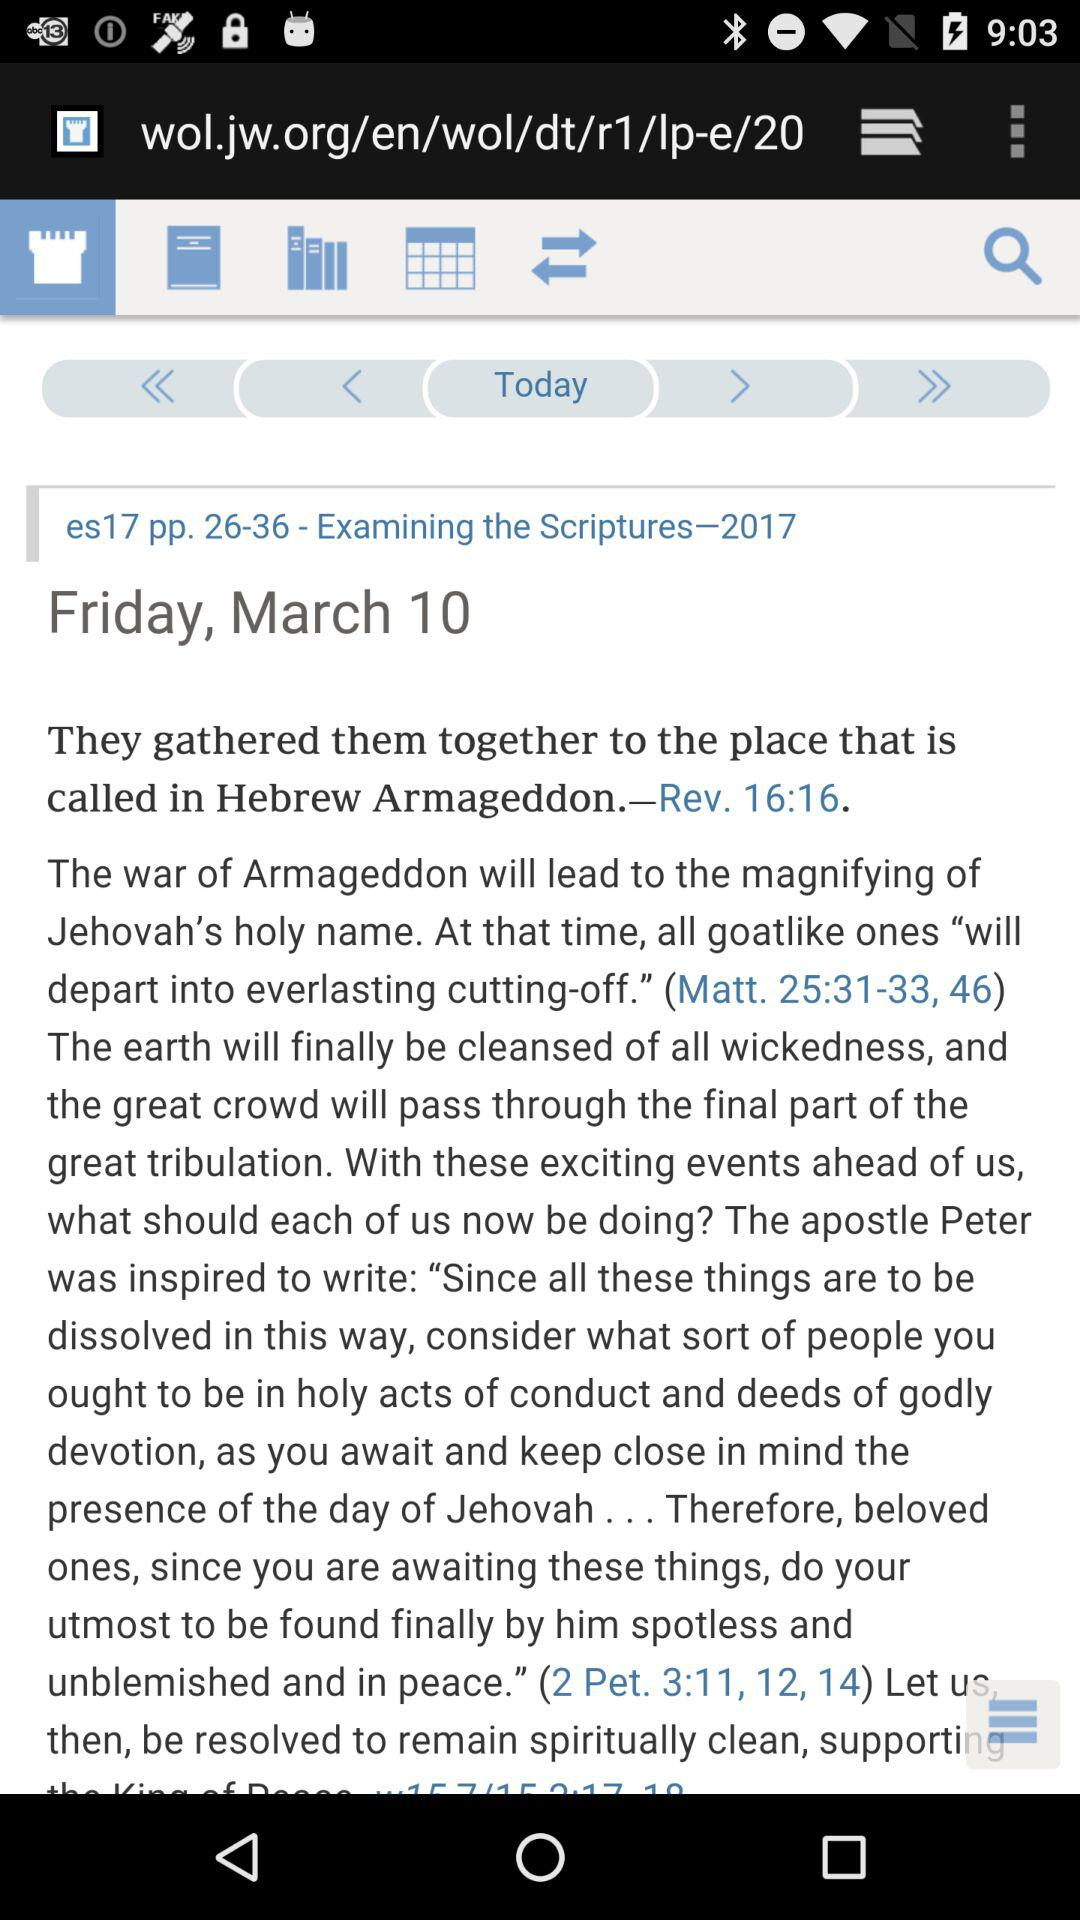What is the date for examining the scriptures? The date is Friday, March 10. 